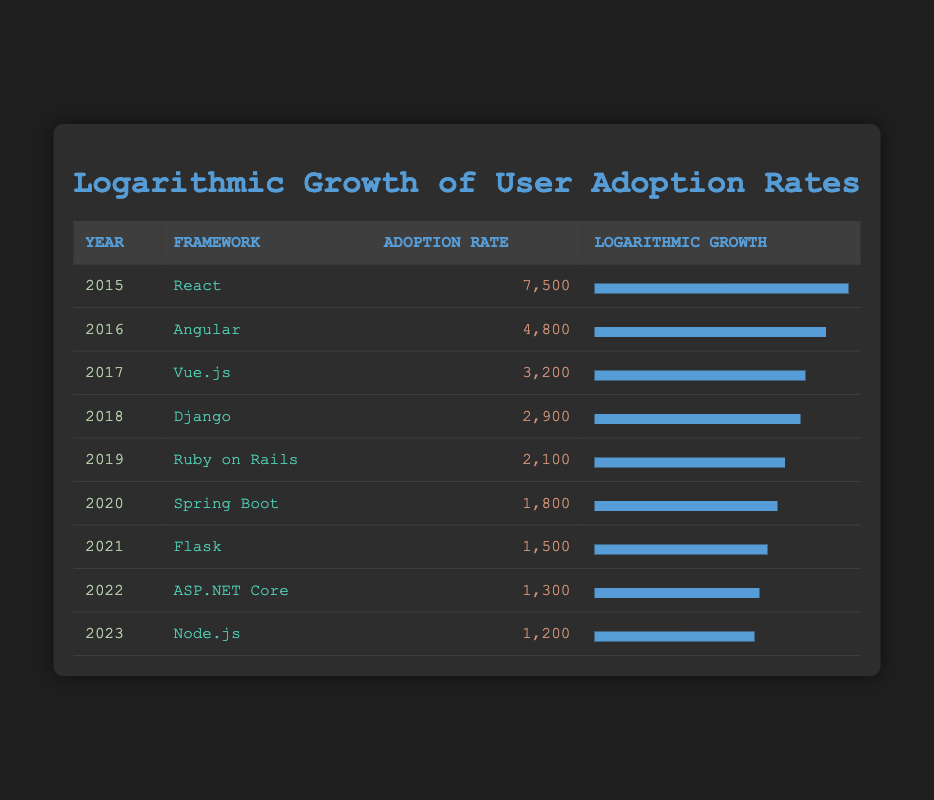What was the adoption rate of React in 2015? The table lists the adoption rate of React for the year 2015 as 7,500, which is directly shown in the corresponding row.
Answer: 7,500 Which framework had the lowest adoption rate in 2023? According to the table, Node.js had the lowest adoption rate at 1,200 for the year 2023. This is determined by comparing the adoption rates for all frameworks listed for that year.
Answer: Node.js What is the difference in adoption rates between Angular in 2016 and Flask in 2021? The adoption rate of Angular in 2016 is 4,800 while Flask in 2021 is 1,500. The difference is calculated as 4,800 - 1,500 = 3,300.
Answer: 3,300 Was the adoption rate of Django in 2018 higher than that of Ruby on Rails in 2019? The adoption rate of Django in 2018 is 2,900 and for Ruby on Rails in 2019 is 2,100. Since 2,900 is greater than 2,100, the statement is true.
Answer: Yes What is the average adoption rate of all the frameworks listed in the table? To find the average, we first sum the adoption rates: 7,500 + 4,800 + 3,200 + 2,900 + 2,100 + 1,800 + 1,500 + 1,300 + 1,200 = 26,300. There are 9 frameworks, so the average adoption rate is 26,300 / 9 = 2,922.22.
Answer: 2,922.22 Which framework showed a logarithmic growth width closest to 70%? The logarithmic growth widths can be seen in the table; both Spring Boot (72%) and Flask (68%) are close to 70%. Hence, both frameworks are relevant for this question.
Answer: Spring Boot and Flask How many frameworks had an adoption rate lower than 2,000 from 2019 to 2023? The relevant adoption rates are: Ruby on Rails (2,100), Spring Boot (1,800), Flask (1,500), ASP.NET Core (1,300), and Node.js (1,200). Only 4 frameworks are below 2,000 in that period: Spring Boot, Flask, ASP.NET Core, and Node.js.
Answer: 4 Is the adoption rate of ASP.NET Core increasing from the year 2022 to 2023? The adoption rate of ASP.NET Core in 2022 is 1,300 and in 2023 is 1,200. Since 1,200 is less than 1,300, the adoption rate decreased.
Answer: No Which framework had a higher adoption rate, Vue.js in 2017 or Django in 2018? The adoption rate for Vue.js in 2017 was 3,200, while Django's adoption rate in 2018 was 2,900. Since 3,200 is greater than 2,900, Vue.js has a higher adoption rate than Django.
Answer: Vue.js 